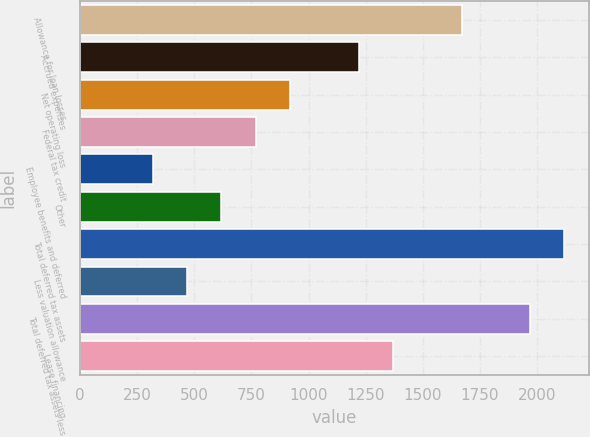Convert chart. <chart><loc_0><loc_0><loc_500><loc_500><bar_chart><fcel>Allowance for loan losses<fcel>Accrued expenses<fcel>Net operating loss<fcel>Federal tax credit<fcel>Employee benefits and deferred<fcel>Other<fcel>Total deferred tax assets<fcel>Less valuation allowance<fcel>Total deferred tax assets less<fcel>Lease financing<nl><fcel>1669.2<fcel>1218.6<fcel>918.2<fcel>768<fcel>317.4<fcel>617.8<fcel>2119.8<fcel>467.6<fcel>1969.6<fcel>1368.8<nl></chart> 